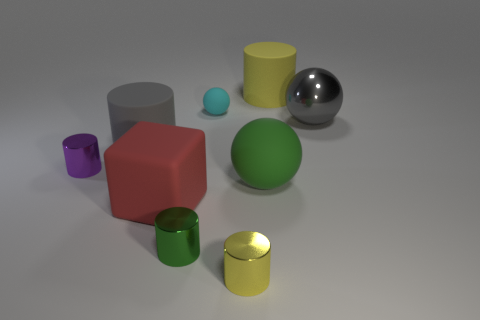Subtract all big shiny spheres. How many spheres are left? 2 Subtract all red blocks. How many yellow cylinders are left? 2 Add 1 green cylinders. How many objects exist? 10 Subtract all gray cylinders. How many cylinders are left? 4 Subtract all spheres. How many objects are left? 6 Subtract 2 cylinders. How many cylinders are left? 3 Subtract all gray cylinders. Subtract all purple spheres. How many cylinders are left? 4 Add 4 small purple cylinders. How many small purple cylinders are left? 5 Add 6 big red matte things. How many big red matte things exist? 7 Subtract 1 gray balls. How many objects are left? 8 